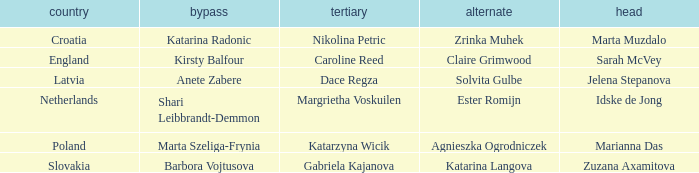What is the name of the second who has Caroline Reed as third? Claire Grimwood. 